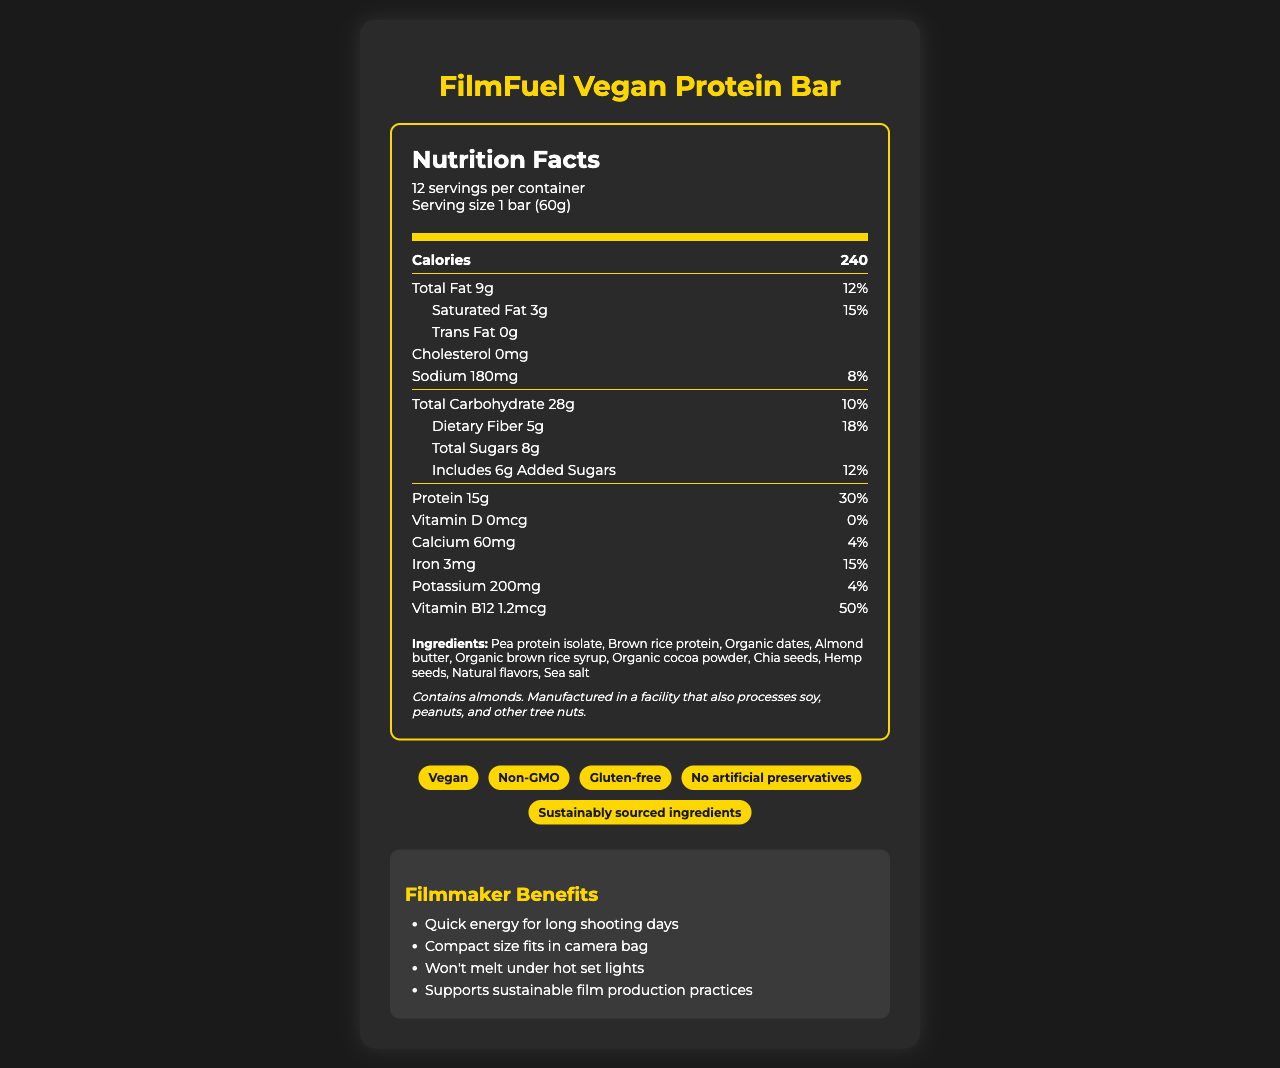what is the serving size of the FilmFuel Vegan Protein Bar? The serving size is listed as "1 bar (60g)" under the nutrition header.
Answer: 1 bar (60g) how many total calories are in one serving of the FilmFuel Vegan Protein Bar? Under the "Calories" section, it is specified that one serving contains 240 calories.
Answer: 240 how many grams of protein does one FilmFuel Vegan Protein Bar contain? The amount of protein is indicated as 15g in the nutrition facts.
Answer: 15g is there any cholesterol in the FilmFuel Vegan Protein Bar? The nutrition facts clearly state "Cholesterol 0mg," indicating there is no cholesterol.
Answer: No what are the top three ingredients in the FilmFuel Vegan Protein Bar? The first three ingredients listed are Pea protein isolate, Brown rice protein, and Organic dates.
Answer: Pea protein isolate, Brown rice protein, Organic dates what percentage of the daily value of saturated fat does the FilmFuel Vegan Protein Bar provide? Under the saturated fat section, it is listed as contributing 15% of the daily value.
Answer: 15% what is the total fat content in one serving of the FilmFuel Vegan Protein Bar? The total fat content is listed as 9g under the "Total Fat" section.
Answer: 9g how much dietary fiber does one FilmFuel Vegan Protein Bar contain? The dietary fiber content is specified as 5g under the relevant section.
Answer: 5g how much iron is present in one serving of the FilmFuel Vegan Protein Bar? The amount of iron in one serving is listed as 3mg.
Answer: 3mg how many servings are in one container of the FilmFuel Vegan Protein Bar? It is indicated that there are 12 servings per container just below the product name.
Answer: 12 which of the following is NOT listed as an ingredient in the FilmFuel Vegan Protein Bar? A. Organic brown rice syrup B. Sea salt C. Sugar D. Chia seeds The ingredients listed include Organic brown rice syrup, Sea salt, and Chia seeds, but not Sugar.
Answer: C does the FilmFuel Vegan Protein Bar contain any added sugars? The label states "Includes 6g Added Sugars" under the "Total Sugars" section.
Answer: Yes is the FilmFuel Vegan Protein Bar suitable for someone with a peanut allergy? The allergen information indicates that it is manufactured in a facility that processes peanuts, but does not specify contamination levels.
Answer: I don't know summarize the main idea of the FilmFuel Vegan Protein Bar's nutrition facts label. This document describes the nutritional content, main ingredients, and allergen information of the FilmFuel Vegan Protein Bar, highlighting its suitability for vegan diets and on-the-go filmmaking needs. It also emphasizes its sustainability and various health claims.
Answer: The FilmFuel Vegan Protein Bar is a vegan, non-GMO, and gluten-free product designed for filmmakers, providing essential nutrients like protein and dietary fiber, with key benefits for on-the-go energy and sustainable production. It contains almonds and is manufactured in a facility processing various allergens. how much potassium is in one serving of the FilmFuel Vegan Protein Bar? The nutrition label lists potassium content as 200mg per serving.
Answer: 200mg what are the filmmaker benefits of the FilmFuel Vegan Protein Bar? These benefits are explicitly listed under the section "Filmmaker Benefits."
Answer: Quick energy for long shooting days, Compact size fits in camera bag, Won't melt under hot set lights, Supports sustainable film production practices does the nutrition label specify the sugar source? The ingredients list contains general terms like Organic dates and Organic brown rice syrup but does not specify the exact sugar sources.
Answer: No 